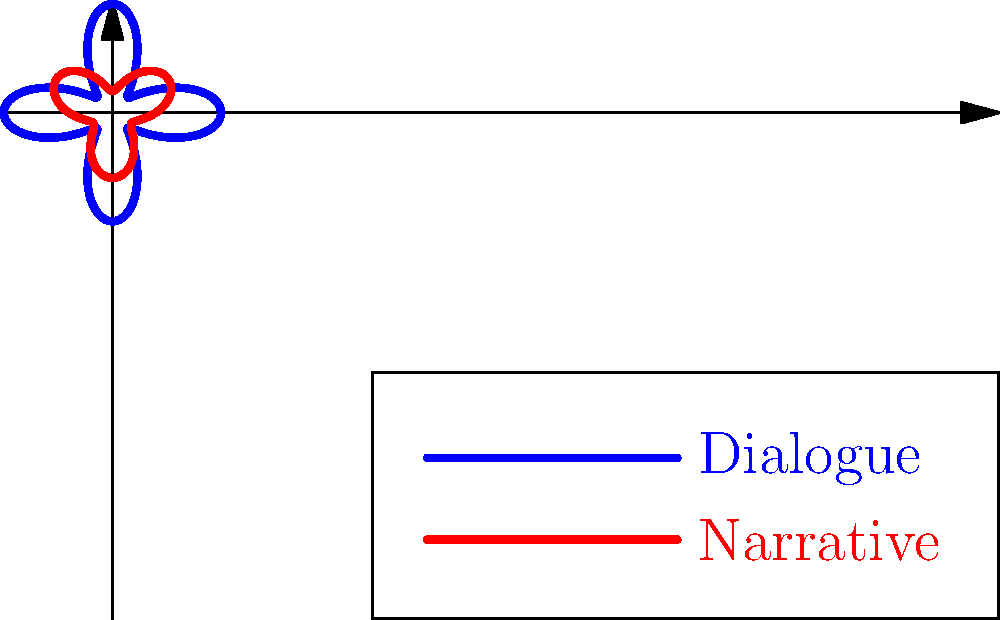In the polar rose plot above, which represents the balance between dialogue and narrative in a story, what does the blue curve indicate about the dialogue compared to the red curve representing the narrative? To interpret this polar rose plot:

1. The blue curve represents dialogue, while the red curve represents narrative.
2. The distance from the center at any given angle represents the intensity or prominence of that element at that point in the story.
3. The blue (dialogue) curve has four distinct lobes, indicating regular patterns or cycles in dialogue intensity.
4. The red (narrative) curve has three lobes, showing a different cyclical pattern for narrative intensity.
5. The blue curve generally extends further from the center than the red curve.
6. This greater extension suggests that dialogue is more prominent or dominant in the story overall.
7. However, there are points where the red curve extends beyond the blue, indicating moments where narrative takes precedence.
8. The complexity of both curves suggests a dynamic interplay between dialogue and narrative throughout the story.

Given these observations, we can conclude that the blue curve (dialogue) indicates a generally higher prominence or intensity compared to the narrative, with more frequent peaks and a larger overall area covered by the curve.
Answer: Higher prominence and intensity with more frequent peaks 